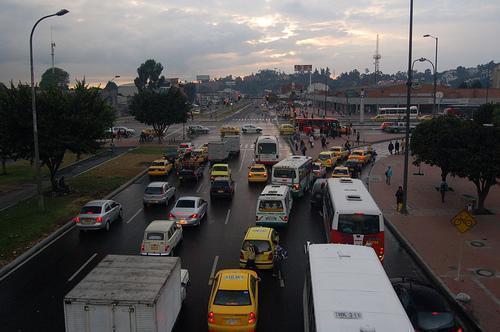What picture is on the sign that is all the way to the right?
Pick the right solution, then justify: 'Answer: answer
Rationale: rationale.'
Options: Baby, cabbage, horse, bicycle. Answer: bicycle.
Rationale: The bicycle is on the sign. 